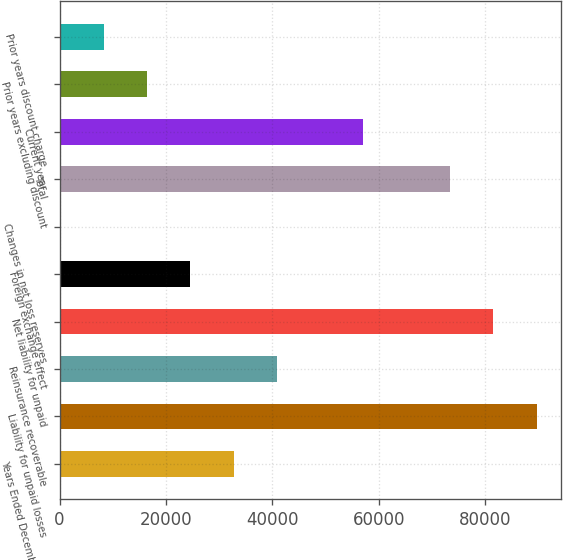Convert chart. <chart><loc_0><loc_0><loc_500><loc_500><bar_chart><fcel>Years Ended December 31 (in<fcel>Liability for unpaid losses<fcel>Reinsurance recoverable<fcel>Net liability for unpaid<fcel>Foreign exchange effect<fcel>Changes in net loss reserves<fcel>Total<fcel>Current year<fcel>Prior years excluding discount<fcel>Prior years discount charge<nl><fcel>32703.4<fcel>89687.6<fcel>40844<fcel>81547<fcel>24562.8<fcel>141<fcel>73406.4<fcel>57125.2<fcel>16422.2<fcel>8281.6<nl></chart> 